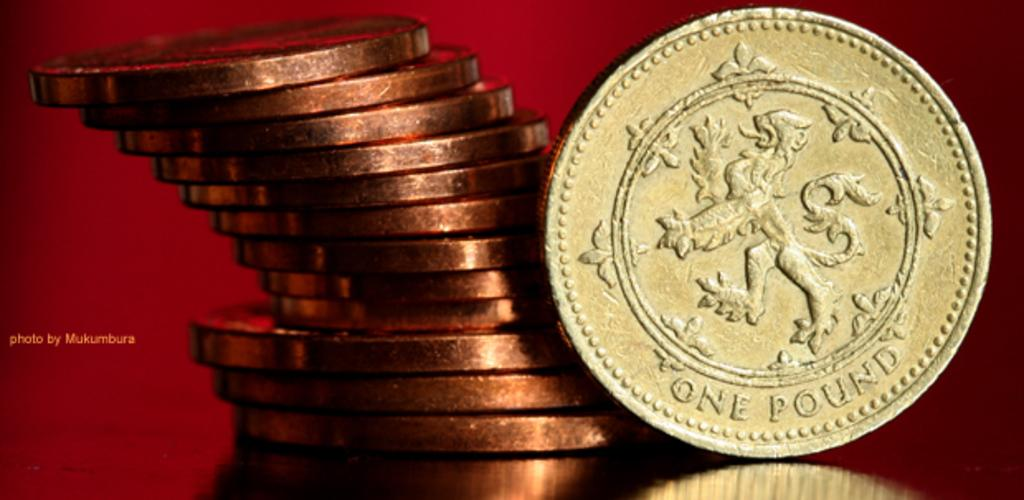<image>
Relay a brief, clear account of the picture shown. a stack of gold coins with one coin leaning on it that says 'one pound' on it 